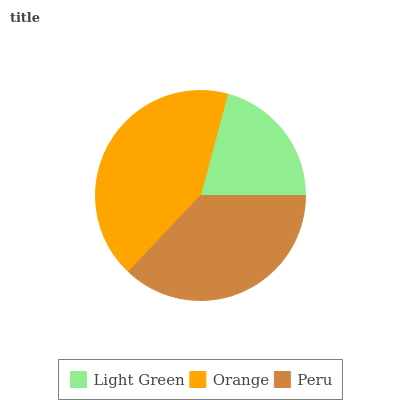Is Light Green the minimum?
Answer yes or no. Yes. Is Orange the maximum?
Answer yes or no. Yes. Is Peru the minimum?
Answer yes or no. No. Is Peru the maximum?
Answer yes or no. No. Is Orange greater than Peru?
Answer yes or no. Yes. Is Peru less than Orange?
Answer yes or no. Yes. Is Peru greater than Orange?
Answer yes or no. No. Is Orange less than Peru?
Answer yes or no. No. Is Peru the high median?
Answer yes or no. Yes. Is Peru the low median?
Answer yes or no. Yes. Is Light Green the high median?
Answer yes or no. No. Is Light Green the low median?
Answer yes or no. No. 